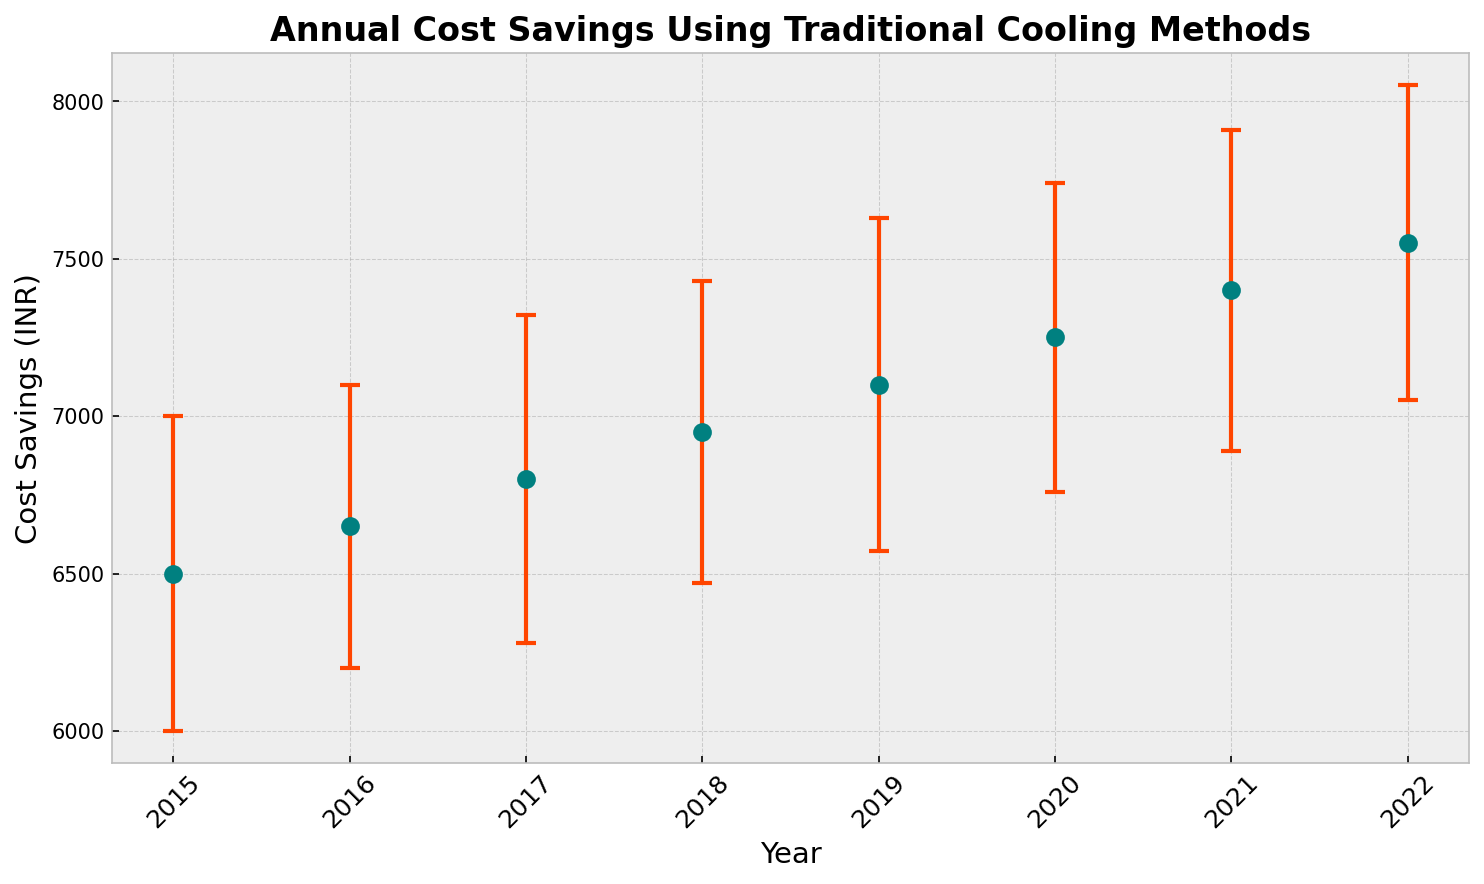What is the trend shown in the annual cost savings from 2015 to 2022? To determine the trend, examine the data points of cost savings over the years. Each year, the cost savings increase compared to the previous year. This consistent upward movement indicates a positive trend.
Answer: Increasing trend What is the average annual cost savings between 2015 and 2022? Sum the cost savings from each year: 6500 + 6650 + 6800 + 6950 + 7100 + 7250 + 7400 + 7550 = 56200. Then divide by the number of years (8): 56200 / 8 = 7025 INR.
Answer: 7025 INR Which year has the highest cost savings? Look at the data points and identify the highest value. The highest cost savings are in 2022, with 7550 INR.
Answer: 2022 What is the difference in cost savings between the years 2015 and 2022? Subtract the cost savings in 2015 from those in 2022: 7550 - 6500 = 1050 INR.
Answer: 1050 INR Which year has the highest uncertainty in cost savings? Compare the uncertainty values for each year. The highest uncertainty, 530 INR, occurs in 2019.
Answer: 2019 Is the cost savings in 2018 greater than in 2016? Compare the cost savings between 2016 (6650 INR) and 2018 (6950 INR). Since 6950 is greater than 6650, cost savings in 2018 are greater.
Answer: Yes What is the average uncertainty in cost savings from 2015 to 2022? Sum all the uncertainty values and divide by the number of years: (500 + 450 + 520 + 480 + 530 + 490 + 510 + 500) / 8 = 3980 / 8 = 497.5 INR.
Answer: 497.5 INR How much greater are the cost savings in 2020 compared to 2019? Subtract the cost savings in 2019 from those in 2020: 7250 - 7100 = 150 INR.
Answer: 150 INR Between 2015 and 2022, which year has the lowest cost savings? Compare the cost savings for each year to identify the smallest value. The lowest cost savings, 6500 INR, occur in 2015.
Answer: 2015 